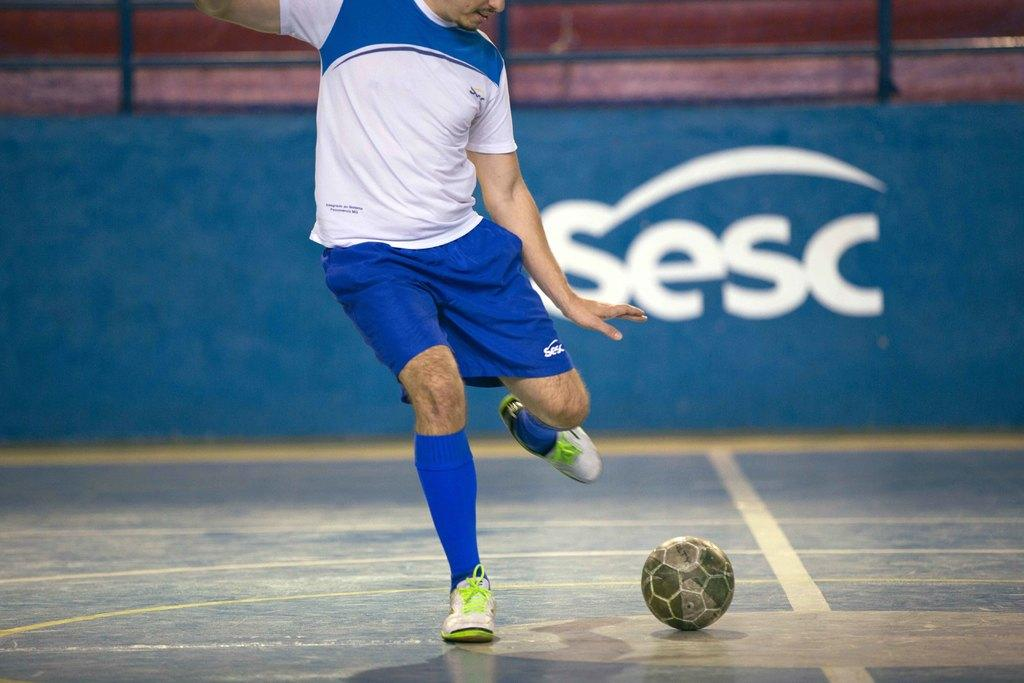What is the main subject of the image? There is a man in the image. What is the man doing in the image? The man is standing on the ground and is about to kick a ball. Where is the ball located in relation to the man? The ball is in front of the man. What can be seen in the background of the image? There is a blue color wall in the background of the image. What type of eggnog is the man holding in the image? There is no eggnog present in the image; the man is about to kick a ball. What does the man hate about the sidewalk in the image? There is no sidewalk or mention of hate in the image; the man is focused on kicking the ball. 